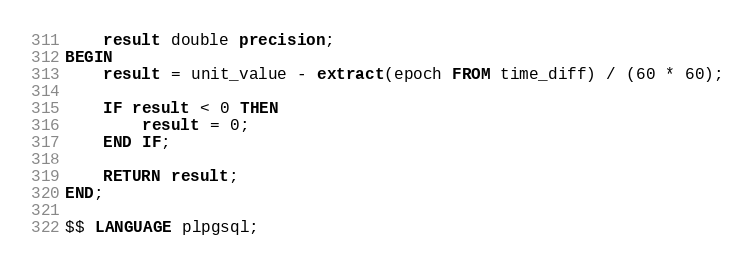Convert code to text. <code><loc_0><loc_0><loc_500><loc_500><_SQL_>    result double precision;
BEGIN
	result = unit_value - extract(epoch FROM time_diff) / (60 * 60);
	
    IF result < 0 THEN
        result = 0;
    END IF;
	
    RETURN result;
END;

$$ LANGUAGE plpgsql;</code> 